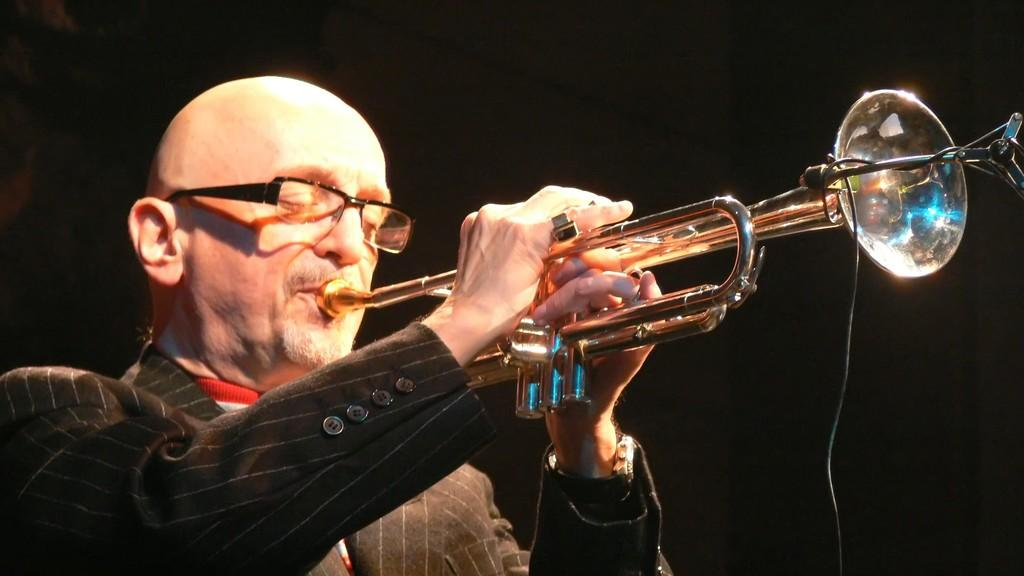What is the main subject of the image? The main subject of the image is a person. What is the person wearing in the image? The person is wearing a suit and glasses in the image. What is the person doing in the image? The person is playing a musical instrument in the image. What is the color of the background in the image? The background of the image is dark. What type of prose can be heard being read by the person in the image? There is no indication in the image that the person is reading or speaking any prose, so it cannot be determined from the picture. 